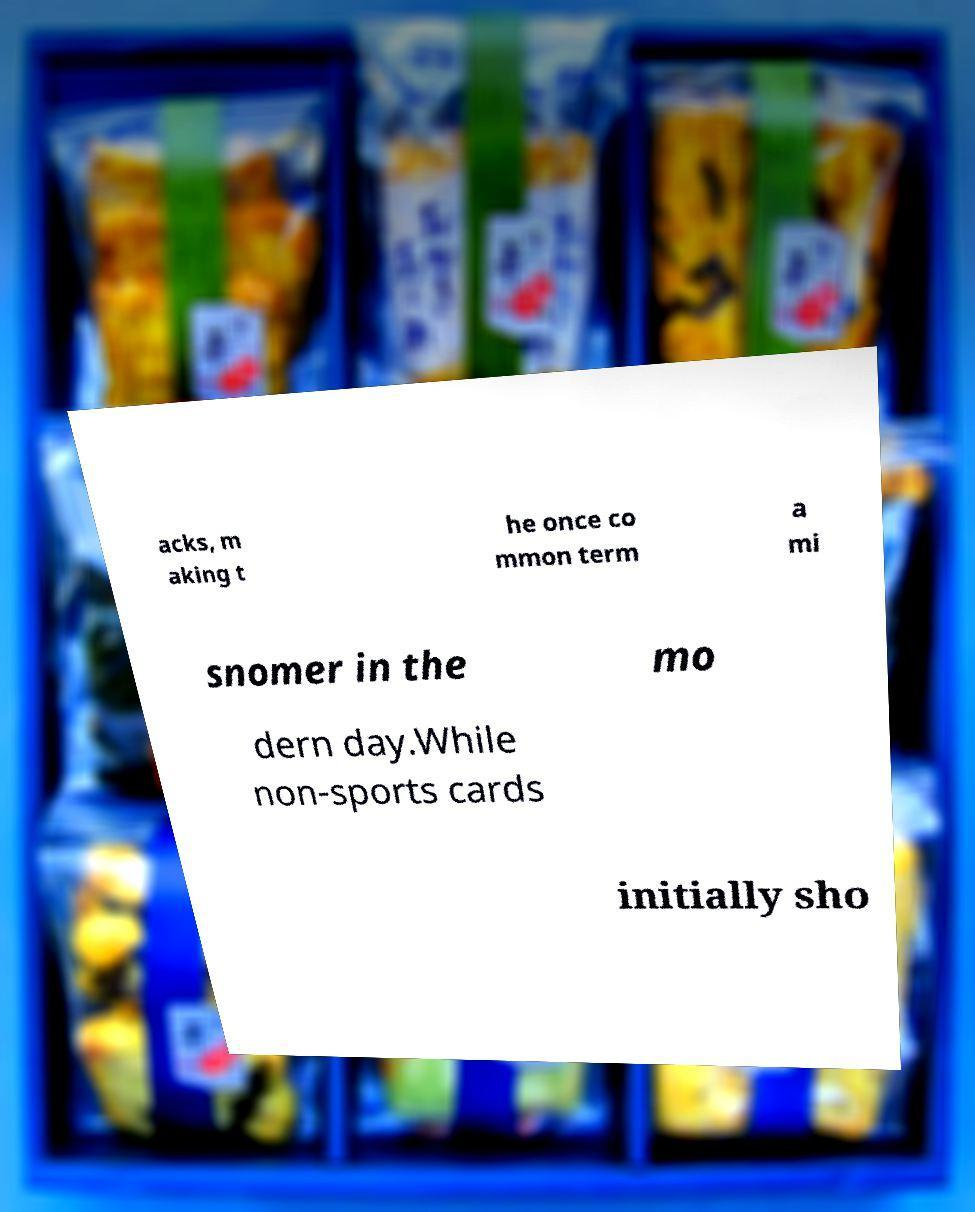What messages or text are displayed in this image? I need them in a readable, typed format. acks, m aking t he once co mmon term a mi snomer in the mo dern day.While non-sports cards initially sho 